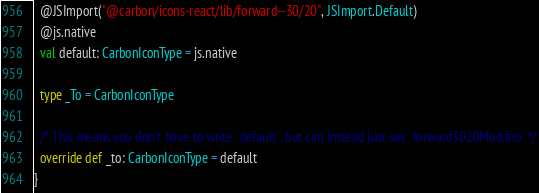Convert code to text. <code><loc_0><loc_0><loc_500><loc_500><_Scala_>  @JSImport("@carbon/icons-react/lib/forward--30/20", JSImport.Default)
  @js.native
  val default: CarbonIconType = js.native
  
  type _To = CarbonIconType
  
  /* This means you don't have to write `default`, but can instead just say `forward3020Mod.foo` */
  override def _to: CarbonIconType = default
}
</code> 